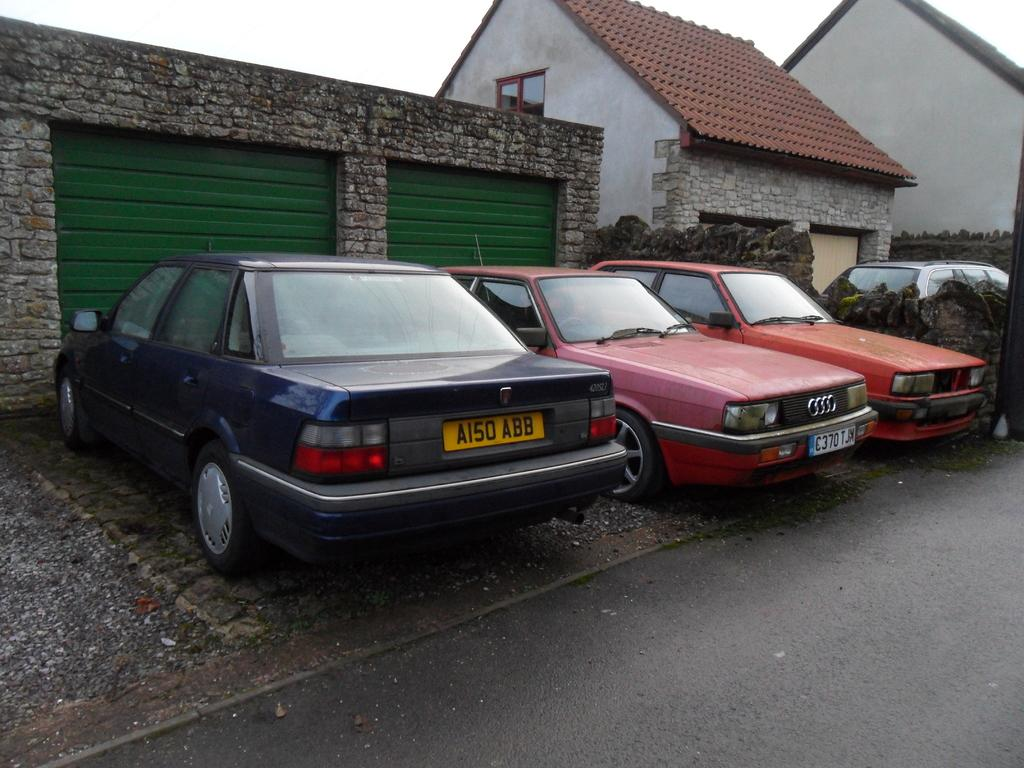What types of objects can be seen in the image? There are vehicles and houses in the image. Can you describe the wall in the image? There is a wall with objects in the image. What is visible on the ground in the image? The ground is visible in the image. What is visible in the sky in the image? The sky is visible in the image. What is the name of the farm in the image? There is no farm present in the image. Can you describe the conversation between the vehicles in the image? Vehicles do not have the ability to talk or engage in conversation, so there is no conversation between them in the image. 